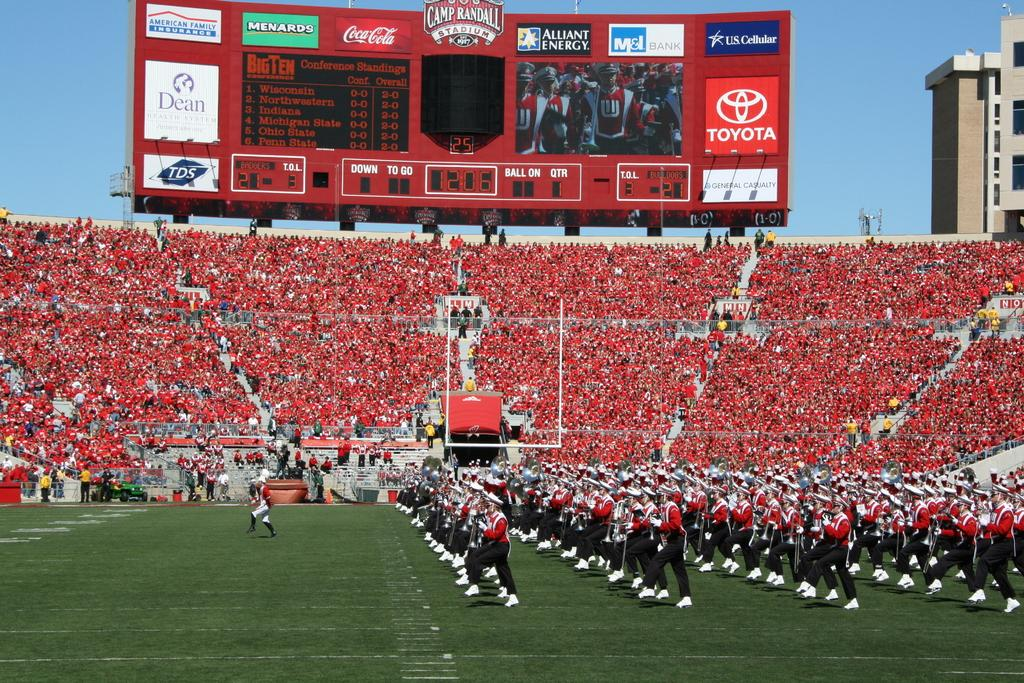<image>
Write a terse but informative summary of the picture. a football game with Toyota on the scoreboard 